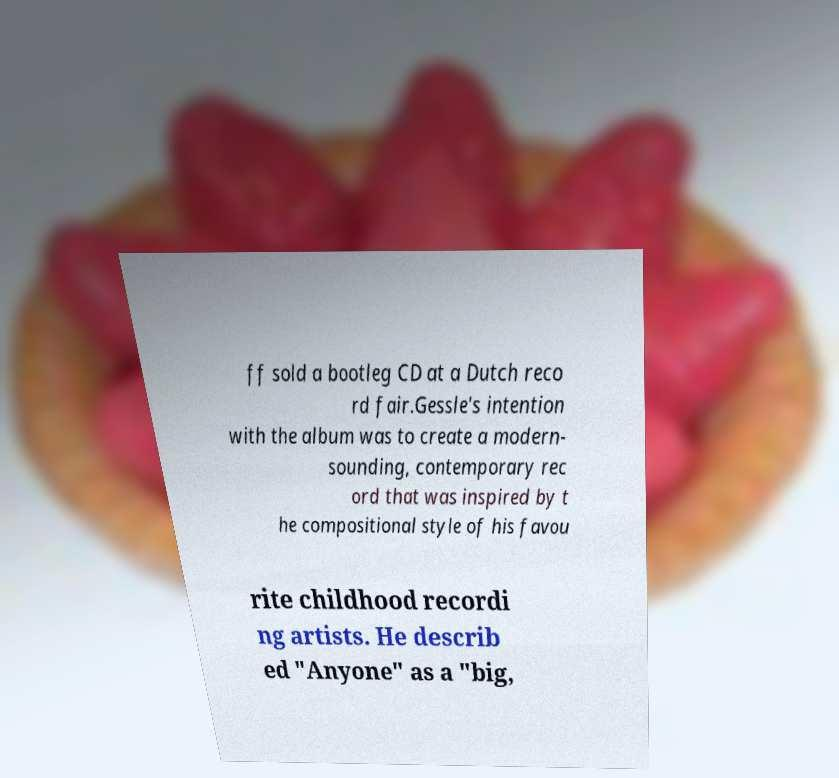Please identify and transcribe the text found in this image. ff sold a bootleg CD at a Dutch reco rd fair.Gessle's intention with the album was to create a modern- sounding, contemporary rec ord that was inspired by t he compositional style of his favou rite childhood recordi ng artists. He describ ed "Anyone" as a "big, 